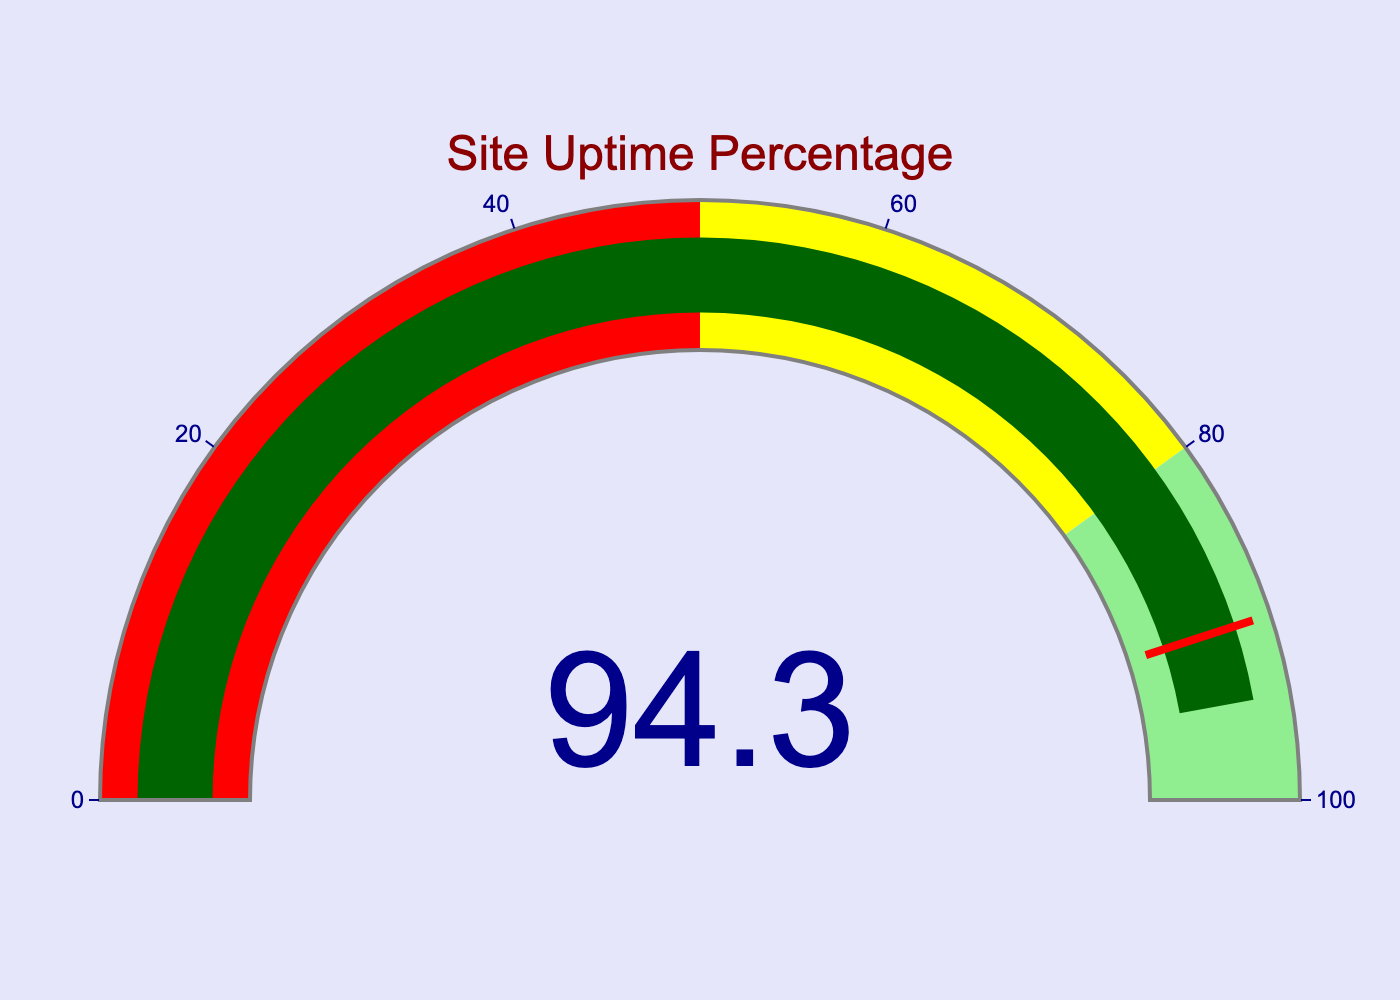what is the site uptime percentage over the last 24 hours? The only number displayed on the gauge indicates the site uptime percentage for the last 24 hours.
Answer: 94.3 What is the title of the gauge chart? The title is displayed at the top of the gauge chart in dark red color and large font size.
Answer: Site Uptime Percentage Is the site uptime percentage considered "good" based on the color coding of the gauge? The gauge has different color segments: red for 0-50, yellow for 50-80, and light green for 80-100. Since 94.3 falls in the light green segment, it indicates a good uptime percentage.
Answer: Yes Does the uptime percentage surpass the threshold indicated in the chart? The threshold is marked at 90 with a red line. The uptime percentage is 94.3, which surpasses this threshold.
Answer: Yes Which color represents the highest range of uptime percentage on the gauge? The color segments represent different ranges: red (0-50), yellow (50-80), and light green (80-100). The highest range (80-100) is represented by light green.
Answer: Light green 